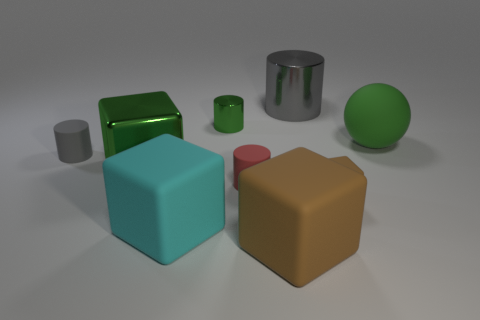Do the tiny metal thing and the metal cube have the same color?
Give a very brief answer. Yes. What number of objects are either small matte objects that are on the left side of the small brown thing or metal things?
Make the answer very short. 5. What is the color of the tiny rubber cylinder in front of the gray thing that is left of the green metal object in front of the big green matte thing?
Ensure brevity in your answer.  Red. What is the color of the big object that is the same material as the large cylinder?
Offer a terse response. Green. How many red things have the same material as the small green object?
Offer a very short reply. 0. There is a rubber cylinder that is in front of the gray rubber cylinder; is its size the same as the gray rubber cylinder?
Your answer should be compact. Yes. The metal block that is the same size as the green sphere is what color?
Your response must be concise. Green. There is a small red thing; how many metallic cubes are on the left side of it?
Your answer should be compact. 1. Are any tiny yellow spheres visible?
Provide a succinct answer. No. There is a cylinder that is in front of the large shiny thing to the left of the big brown block in front of the green metallic block; how big is it?
Provide a short and direct response. Small. 